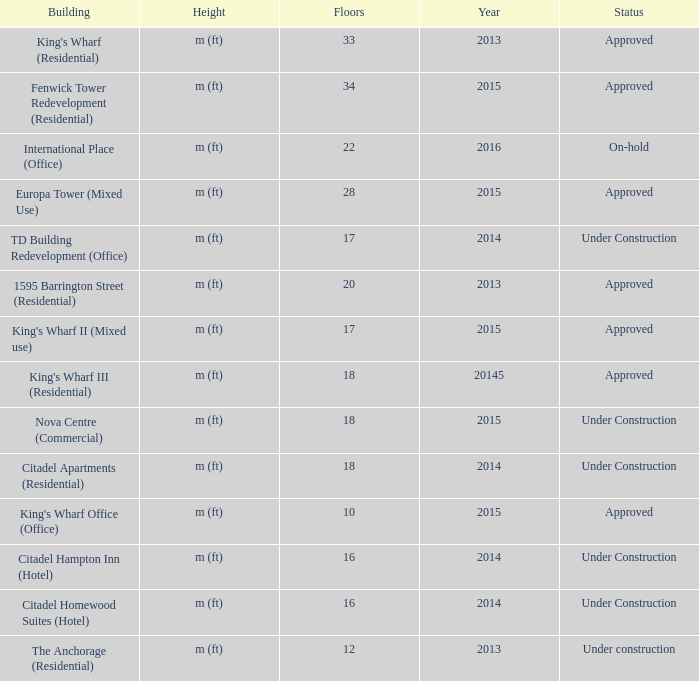In which construction, with 2013 visible, can you find more than 20 floors? King's Wharf (Residential). 